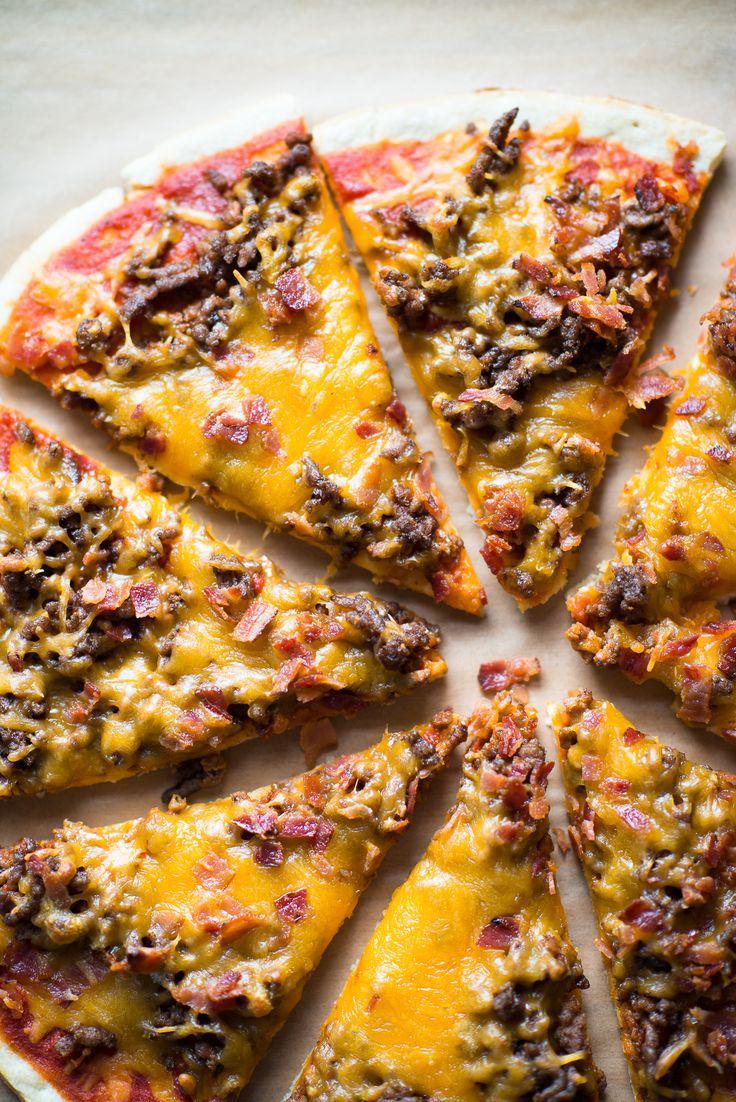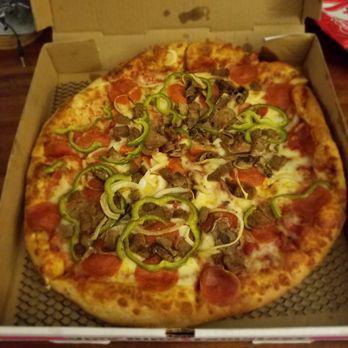The first image is the image on the left, the second image is the image on the right. Analyze the images presented: Is the assertion "One image shows a round pizza with none of its slices missing, sitting in an open cardboard box positioned with the lid at the top." valid? Answer yes or no. Yes. The first image is the image on the left, the second image is the image on the right. Considering the images on both sides, is "There is at least one rectangular shaped pizza." valid? Answer yes or no. No. 